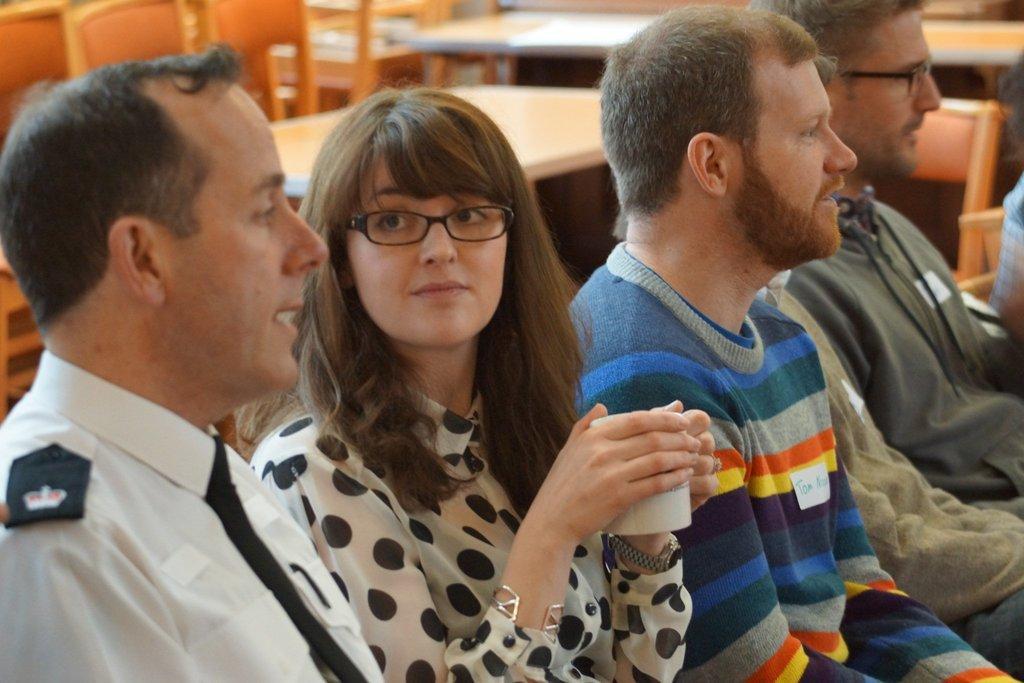Could you give a brief overview of what you see in this image? In this picture we can see a group of people and in the background we can see tables,chairs. 